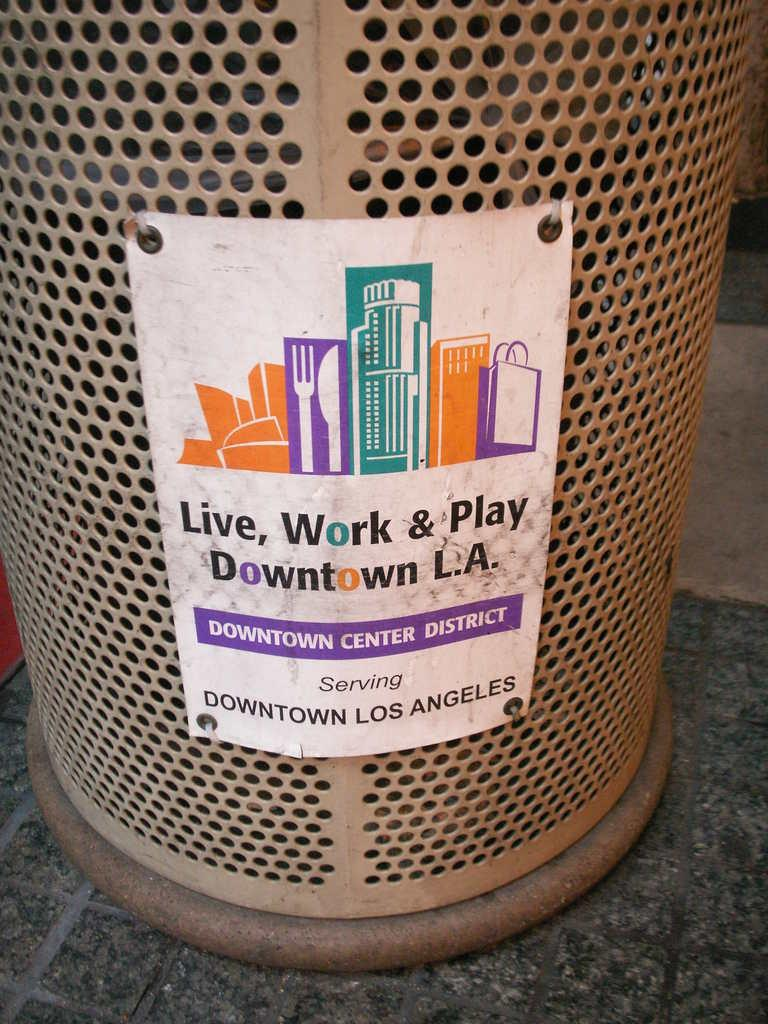<image>
Offer a succinct explanation of the picture presented. A trash bin has a sign on it that says Downtown L.A. 